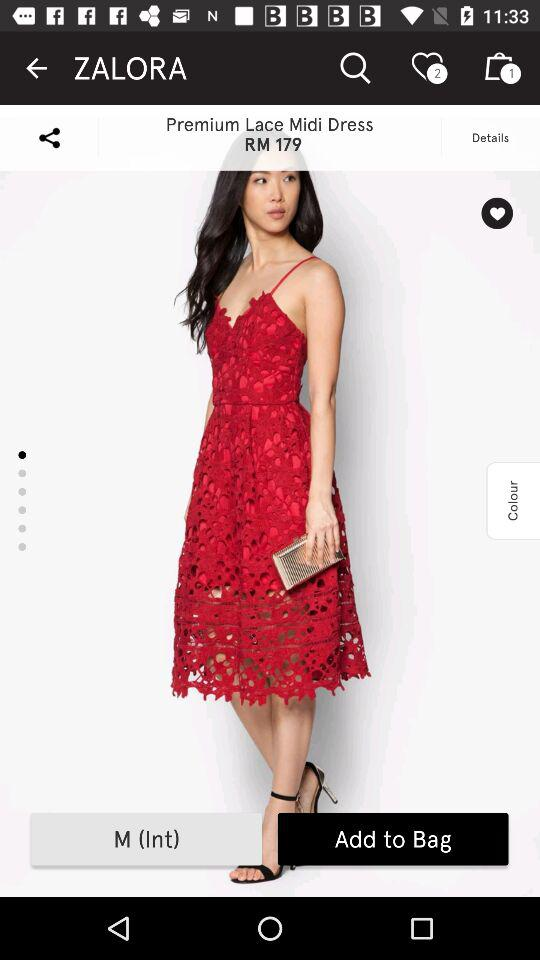How many items are in the bag? There is 1 item in the bag. 